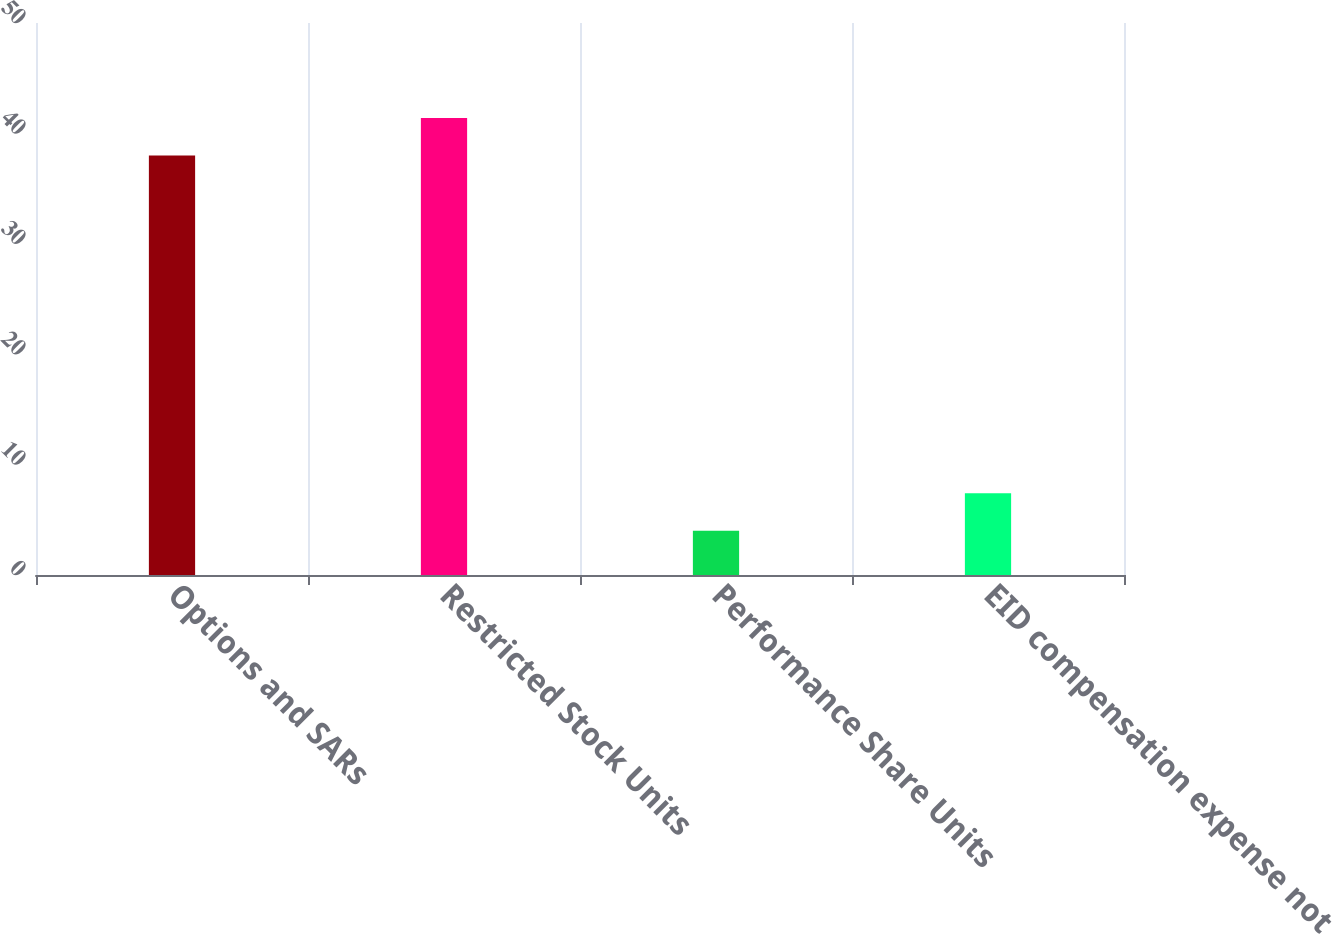Convert chart. <chart><loc_0><loc_0><loc_500><loc_500><bar_chart><fcel>Options and SARs<fcel>Restricted Stock Units<fcel>Performance Share Units<fcel>EID compensation expense not<nl><fcel>38<fcel>41.4<fcel>4<fcel>7.4<nl></chart> 